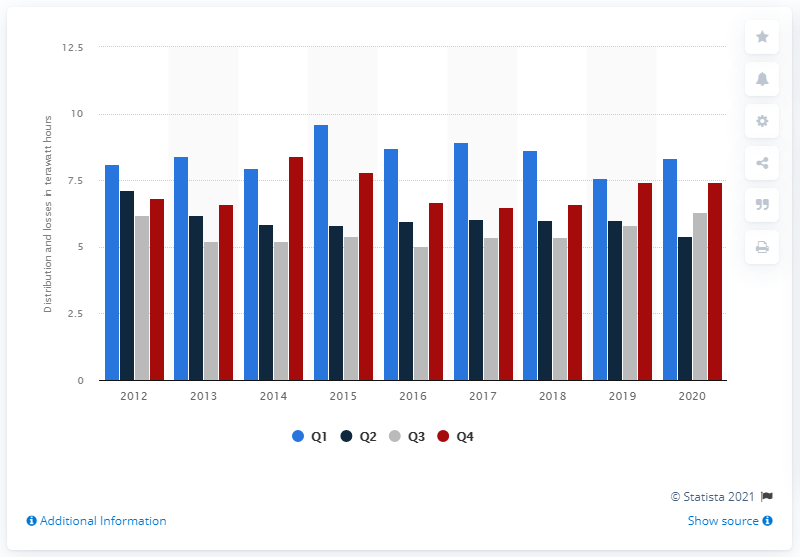Give some essential details in this illustration. In 2012, transmission and other losses in the public electricity system increased during both the first and last quarters of the year. 